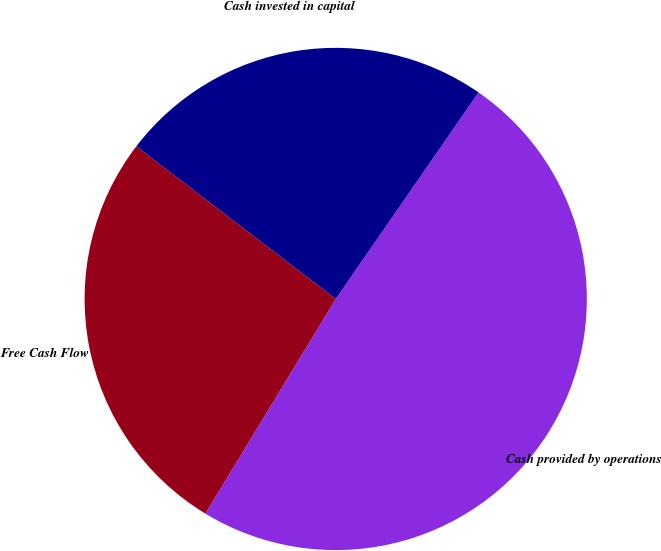<chart> <loc_0><loc_0><loc_500><loc_500><pie_chart><fcel>Cash provided by operations<fcel>Cash invested in capital<fcel>Free Cash Flow<nl><fcel>49.06%<fcel>24.23%<fcel>26.71%<nl></chart> 